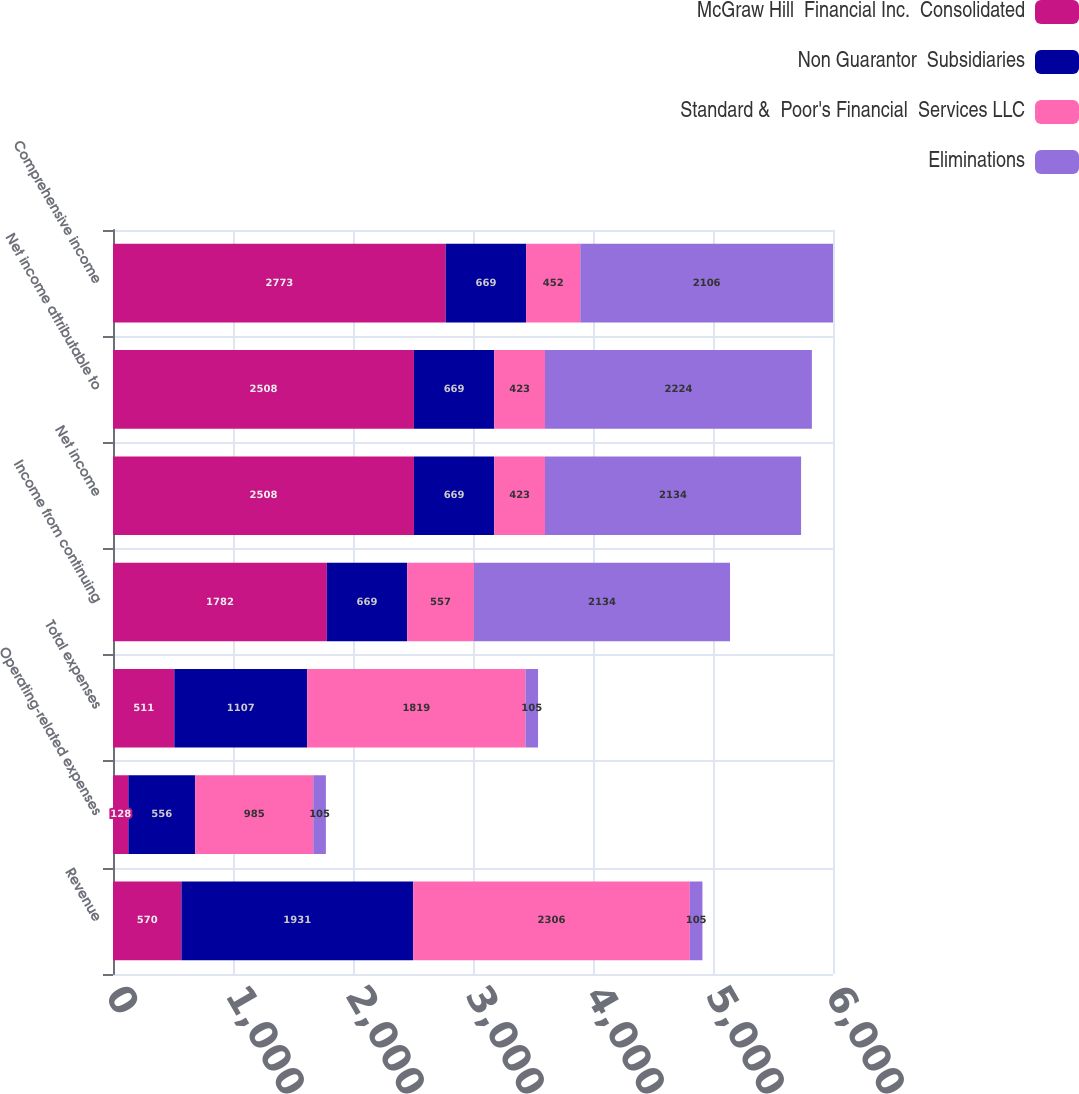Convert chart to OTSL. <chart><loc_0><loc_0><loc_500><loc_500><stacked_bar_chart><ecel><fcel>Revenue<fcel>Operating-related expenses<fcel>Total expenses<fcel>Income from continuing<fcel>Net income<fcel>Net income attributable to<fcel>Comprehensive income<nl><fcel>McGraw Hill  Financial Inc.  Consolidated<fcel>570<fcel>128<fcel>511<fcel>1782<fcel>2508<fcel>2508<fcel>2773<nl><fcel>Non Guarantor  Subsidiaries<fcel>1931<fcel>556<fcel>1107<fcel>669<fcel>669<fcel>669<fcel>669<nl><fcel>Standard &  Poor's Financial  Services LLC<fcel>2306<fcel>985<fcel>1819<fcel>557<fcel>423<fcel>423<fcel>452<nl><fcel>Eliminations<fcel>105<fcel>105<fcel>105<fcel>2134<fcel>2134<fcel>2224<fcel>2106<nl></chart> 